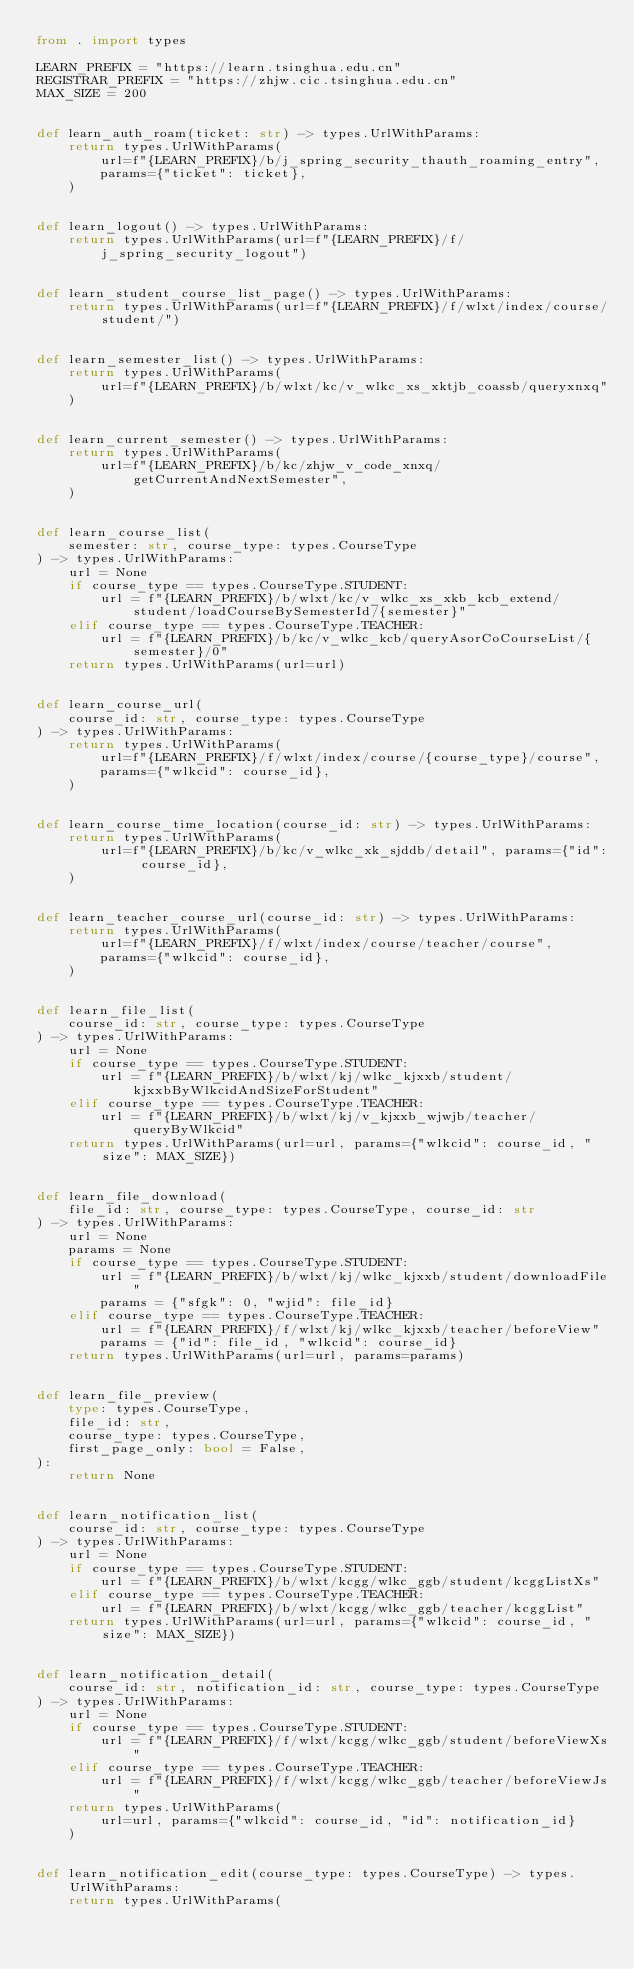<code> <loc_0><loc_0><loc_500><loc_500><_Python_>from . import types

LEARN_PREFIX = "https://learn.tsinghua.edu.cn"
REGISTRAR_PREFIX = "https://zhjw.cic.tsinghua.edu.cn"
MAX_SIZE = 200


def learn_auth_roam(ticket: str) -> types.UrlWithParams:
    return types.UrlWithParams(
        url=f"{LEARN_PREFIX}/b/j_spring_security_thauth_roaming_entry",
        params={"ticket": ticket},
    )


def learn_logout() -> types.UrlWithParams:
    return types.UrlWithParams(url=f"{LEARN_PREFIX}/f/j_spring_security_logout")


def learn_student_course_list_page() -> types.UrlWithParams:
    return types.UrlWithParams(url=f"{LEARN_PREFIX}/f/wlxt/index/course/student/")


def learn_semester_list() -> types.UrlWithParams:
    return types.UrlWithParams(
        url=f"{LEARN_PREFIX}/b/wlxt/kc/v_wlkc_xs_xktjb_coassb/queryxnxq"
    )


def learn_current_semester() -> types.UrlWithParams:
    return types.UrlWithParams(
        url=f"{LEARN_PREFIX}/b/kc/zhjw_v_code_xnxq/getCurrentAndNextSemester",
    )


def learn_course_list(
    semester: str, course_type: types.CourseType
) -> types.UrlWithParams:
    url = None
    if course_type == types.CourseType.STUDENT:
        url = f"{LEARN_PREFIX}/b/wlxt/kc/v_wlkc_xs_xkb_kcb_extend/student/loadCourseBySemesterId/{semester}"
    elif course_type == types.CourseType.TEACHER:
        url = f"{LEARN_PREFIX}/b/kc/v_wlkc_kcb/queryAsorCoCourseList/{semester}/0"
    return types.UrlWithParams(url=url)


def learn_course_url(
    course_id: str, course_type: types.CourseType
) -> types.UrlWithParams:
    return types.UrlWithParams(
        url=f"{LEARN_PREFIX}/f/wlxt/index/course/{course_type}/course",
        params={"wlkcid": course_id},
    )


def learn_course_time_location(course_id: str) -> types.UrlWithParams:
    return types.UrlWithParams(
        url=f"{LEARN_PREFIX}/b/kc/v_wlkc_xk_sjddb/detail", params={"id": course_id},
    )


def learn_teacher_course_url(course_id: str) -> types.UrlWithParams:
    return types.UrlWithParams(
        url=f"{LEARN_PREFIX}/f/wlxt/index/course/teacher/course",
        params={"wlkcid": course_id},
    )


def learn_file_list(
    course_id: str, course_type: types.CourseType
) -> types.UrlWithParams:
    url = None
    if course_type == types.CourseType.STUDENT:
        url = f"{LEARN_PREFIX}/b/wlxt/kj/wlkc_kjxxb/student/kjxxbByWlkcidAndSizeForStudent"
    elif course_type == types.CourseType.TEACHER:
        url = f"{LEARN_PREFIX}/b/wlxt/kj/v_kjxxb_wjwjb/teacher/queryByWlkcid"
    return types.UrlWithParams(url=url, params={"wlkcid": course_id, "size": MAX_SIZE})


def learn_file_download(
    file_id: str, course_type: types.CourseType, course_id: str
) -> types.UrlWithParams:
    url = None
    params = None
    if course_type == types.CourseType.STUDENT:
        url = f"{LEARN_PREFIX}/b/wlxt/kj/wlkc_kjxxb/student/downloadFile"
        params = {"sfgk": 0, "wjid": file_id}
    elif course_type == types.CourseType.TEACHER:
        url = f"{LEARN_PREFIX}/f/wlxt/kj/wlkc_kjxxb/teacher/beforeView"
        params = {"id": file_id, "wlkcid": course_id}
    return types.UrlWithParams(url=url, params=params)


def learn_file_preview(
    type: types.CourseType,
    file_id: str,
    course_type: types.CourseType,
    first_page_only: bool = False,
):
    return None


def learn_notification_list(
    course_id: str, course_type: types.CourseType
) -> types.UrlWithParams:
    url = None
    if course_type == types.CourseType.STUDENT:
        url = f"{LEARN_PREFIX}/b/wlxt/kcgg/wlkc_ggb/student/kcggListXs"
    elif course_type == types.CourseType.TEACHER:
        url = f"{LEARN_PREFIX}/b/wlxt/kcgg/wlkc_ggb/teacher/kcggList"
    return types.UrlWithParams(url=url, params={"wlkcid": course_id, "size": MAX_SIZE})


def learn_notification_detail(
    course_id: str, notification_id: str, course_type: types.CourseType
) -> types.UrlWithParams:
    url = None
    if course_type == types.CourseType.STUDENT:
        url = f"{LEARN_PREFIX}/f/wlxt/kcgg/wlkc_ggb/student/beforeViewXs"
    elif course_type == types.CourseType.TEACHER:
        url = f"{LEARN_PREFIX}/f/wlxt/kcgg/wlkc_ggb/teacher/beforeViewJs"
    return types.UrlWithParams(
        url=url, params={"wlkcid": course_id, "id": notification_id}
    )


def learn_notification_edit(course_type: types.CourseType) -> types.UrlWithParams:
    return types.UrlWithParams(</code> 